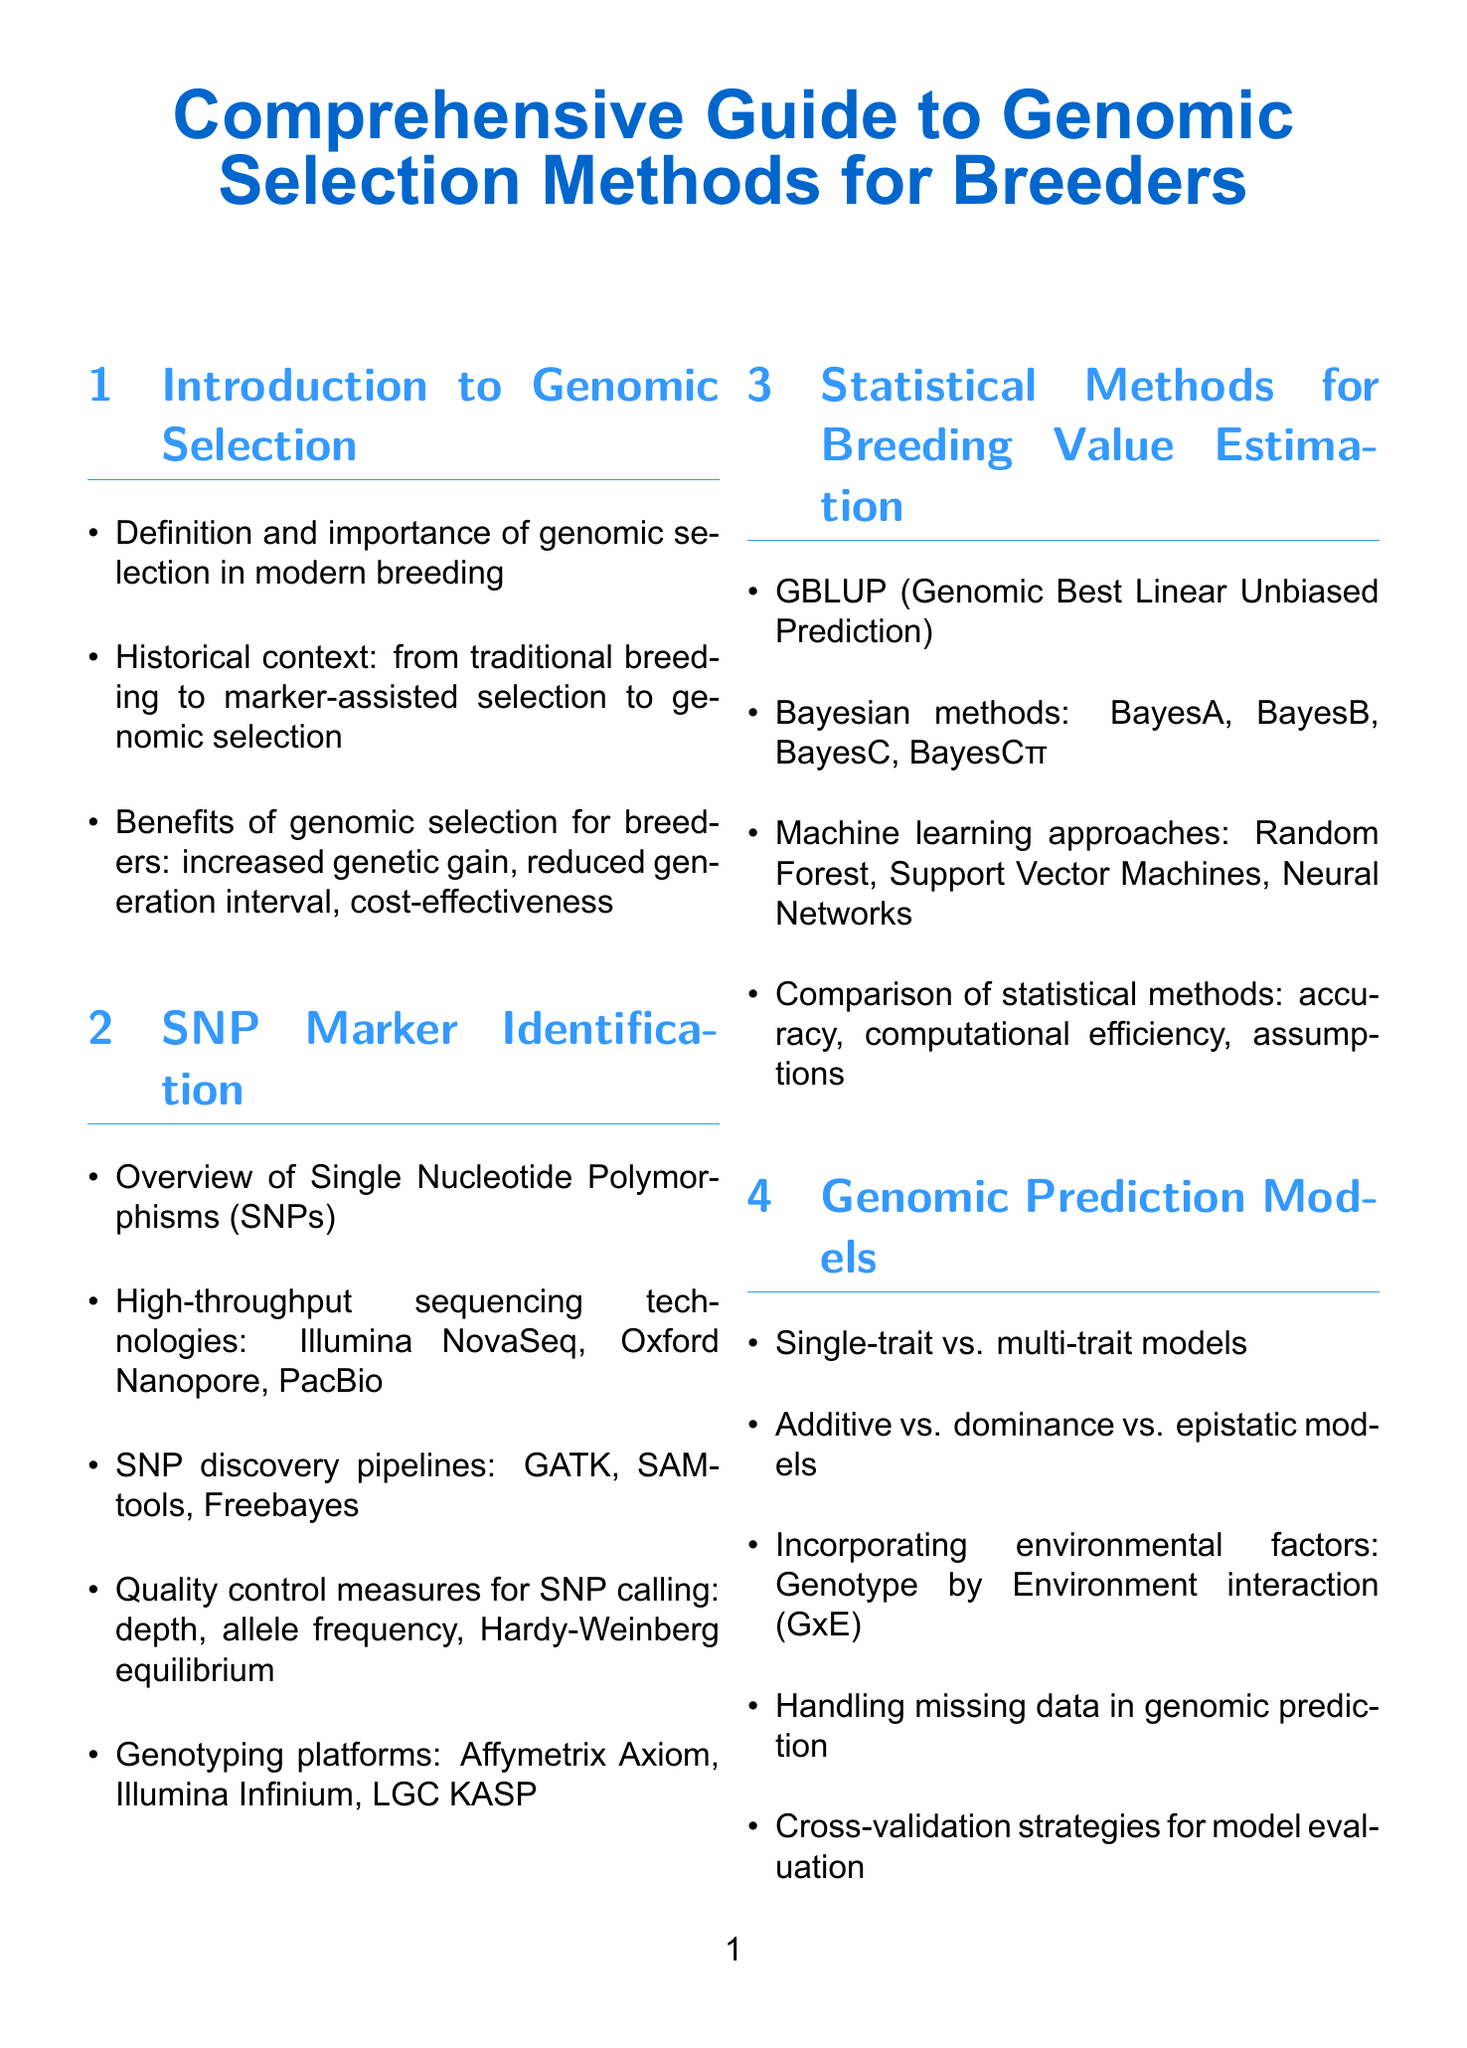What is the title of the document? The title is the main heading of the document, which provides the overall theme.
Answer: Comprehensive Guide to Genomic Selection Methods for Breeders What statistical method is referred to as GBLUP? GBLUP is defined in the section on statistical methods for breeding value estimation.
Answer: Genomic Best Linear Unbiased Prediction Which sequencing technology is mentioned first in SNP marker identification? The first technology listed under SNP marker identification indicates its significance in the context.
Answer: Illumina NovaSeq What are the two types of genomic prediction models discussed? The document lists the types of models used for genomic predictions, highlighting key distinctions.
Answer: Single-trait and multi-trait models Which software package is mentioned for standalone genomic selection? The mention of software tools reflects the variety available for breeders to analyze genomic data.
Answer: AlphaSim What does "GxE" in genomic prediction refer to? The document discusses environmental factors, using this abbreviation to introduce the concept succinctly.
Answer: Genotype by Environment interaction What is one benefit of genomic selection for breeders noted in the introduction? The introduction highlights the advantages of genomic selection, which can enhance breeding efficiency.
Answer: Increased genetic gain What is a challenge for the future of genomic selection mentioned? The challenges section outlines ongoing issues that breeders must consider moving forward.
Answer: Addressing genetic diversity and avoiding inbreeding depression 